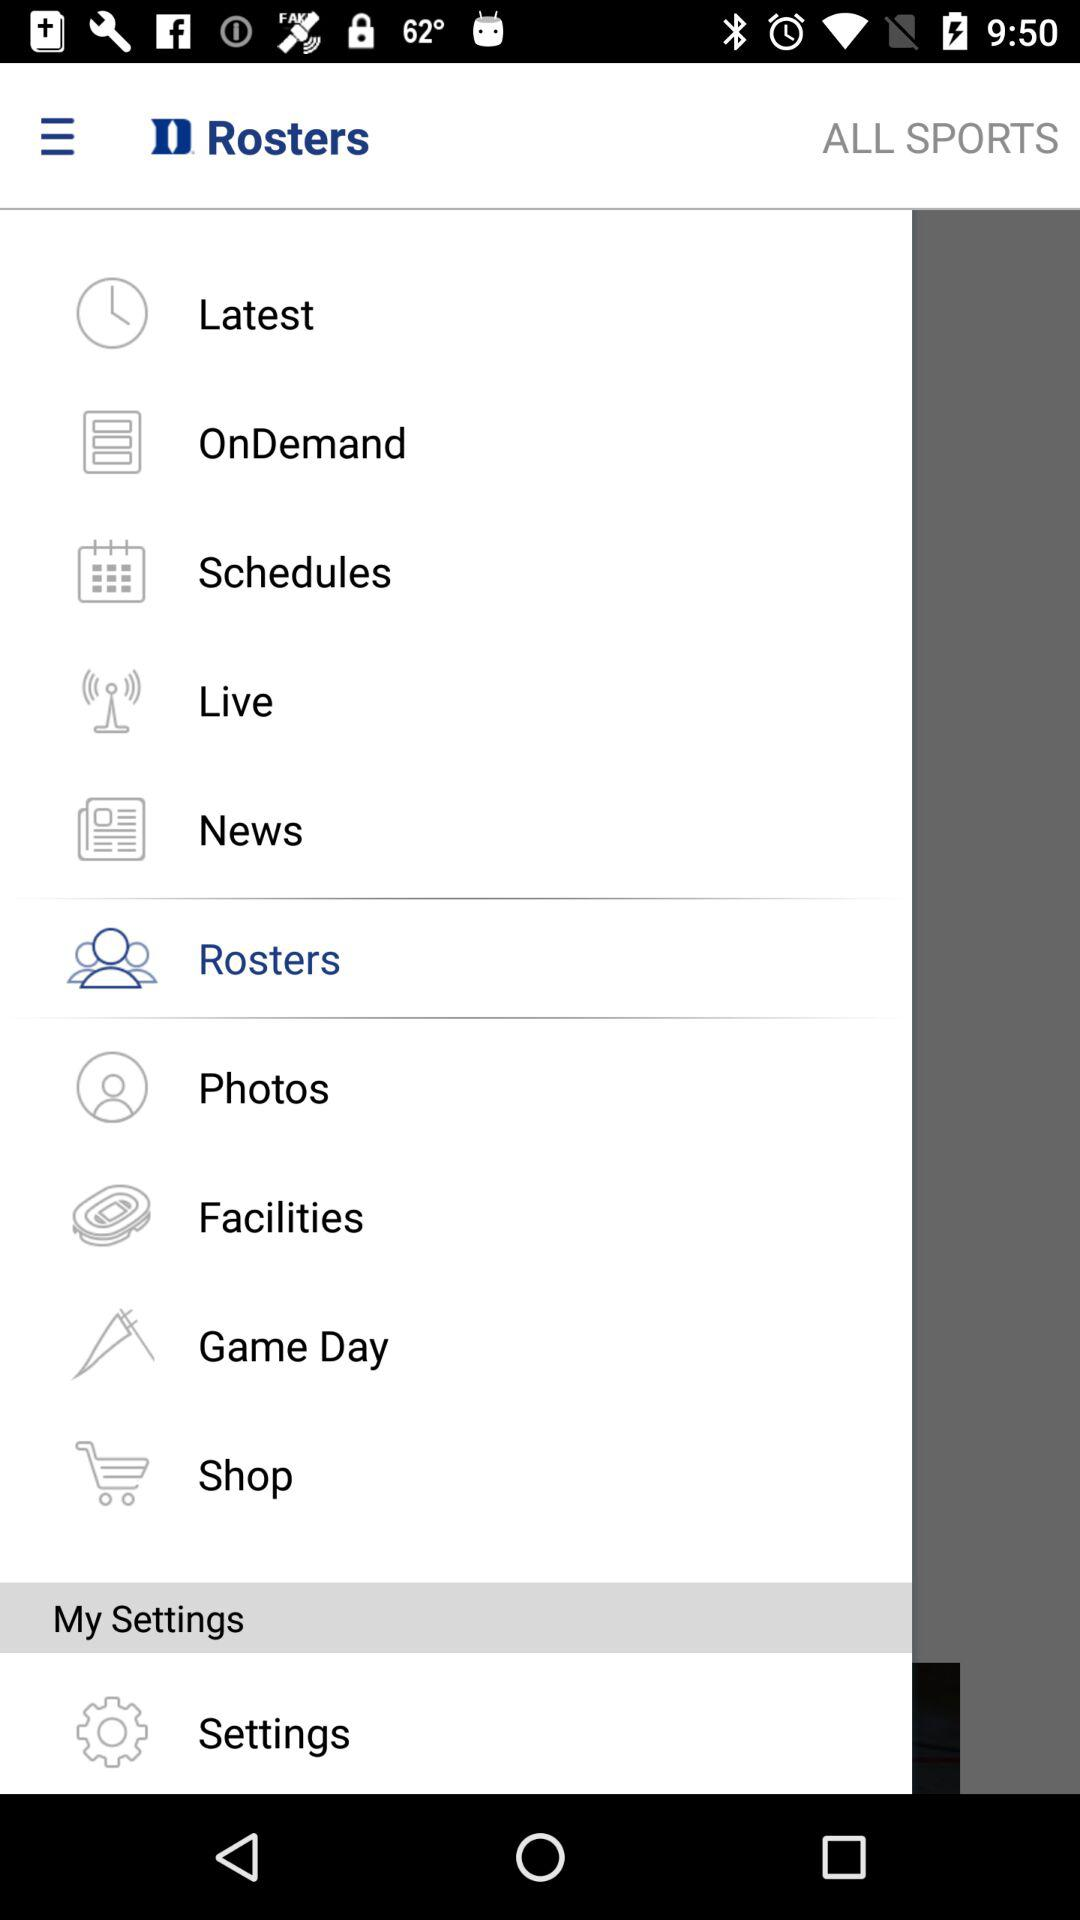Which tab has been selected? The selected tab is "Rosters". 